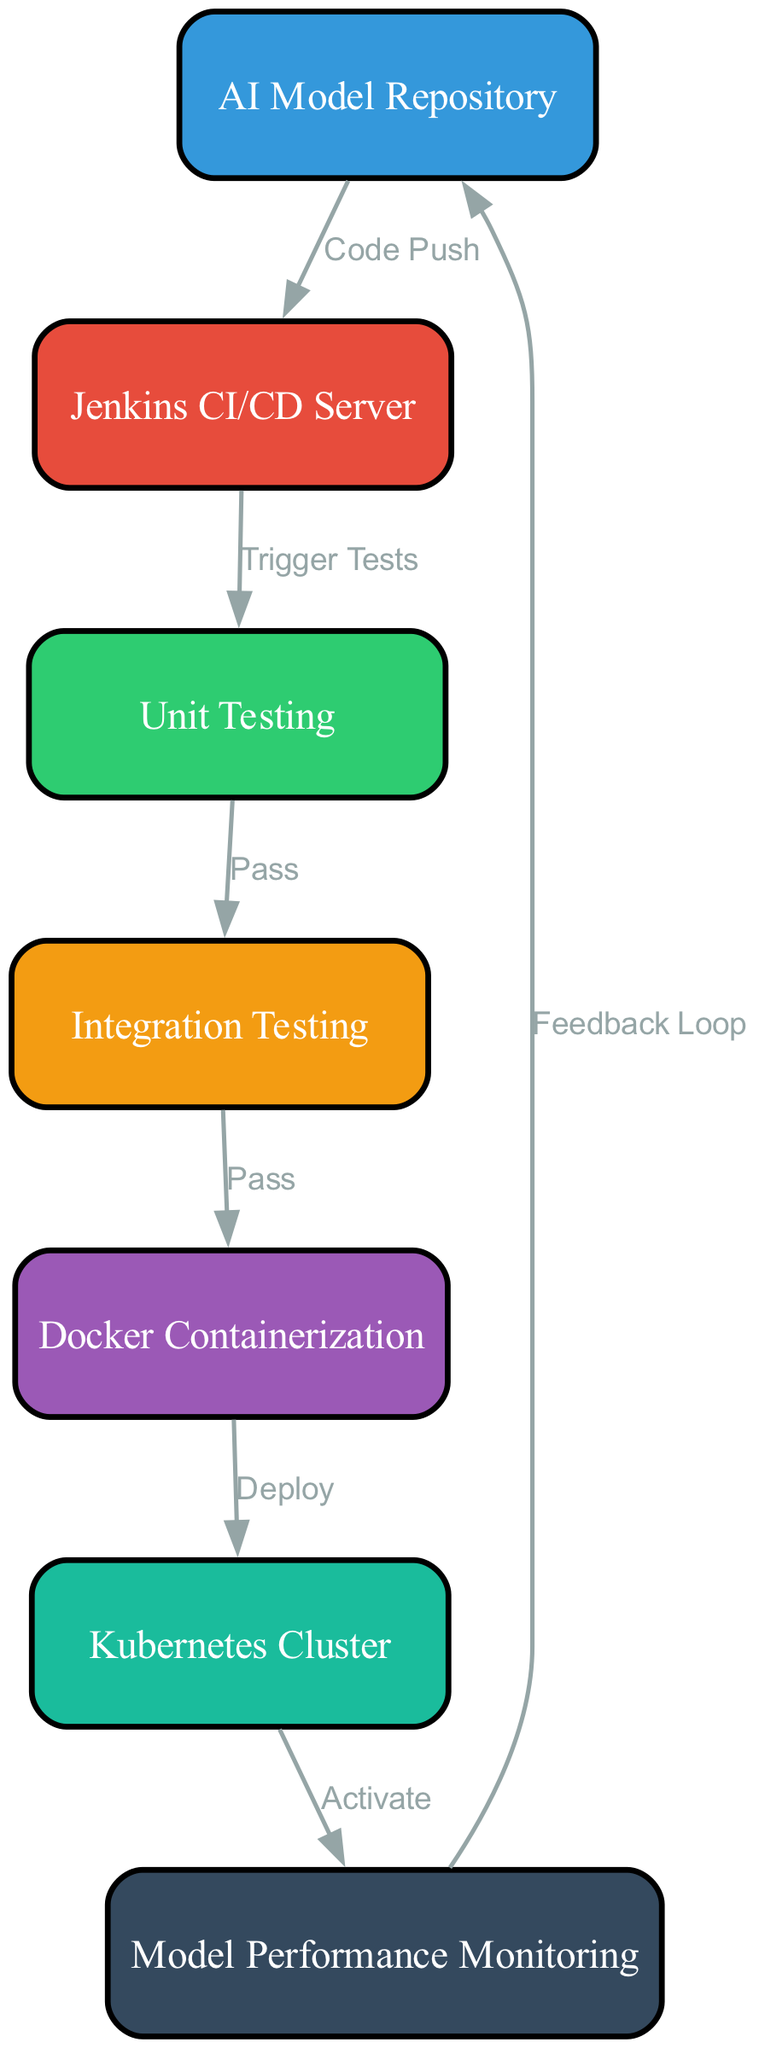What is the starting node of the pipeline? The diagram shows that the starting node is the "AI Model Repository," which is where the code push occurs initially.
Answer: AI Model Repository How many nodes are present in the diagram? By counting each of the nodes listed, we find there are seven nodes in total: AI Model Repository, Jenkins CI/CD Server, Unit Testing, Integration Testing, Docker Containerization, Kubernetes Cluster, and Model Performance Monitoring.
Answer: 7 What is the relationship between the Jenkins CI/CD Server and Unit Testing? The edge connecting these two nodes is labeled "Trigger Tests," indicating that the Jenkins CI/CD Server triggers the unit testing process after receiving a code push.
Answer: Trigger Tests Which node follows Integration Testing? The diagram shows that Integration Testing is followed by Docker Containerization, since the edge labeled "Pass" directly leads from Integration Testing to Docker Containerization.
Answer: Docker Containerization What node is activated after the Kubernetes Cluster? The edge labeled "Activate" leads from the Kubernetes Cluster to Model Performance Monitoring, indicating that Model Performance Monitoring is activated after deploying to the Kubernetes Cluster.
Answer: Model Performance Monitoring What occurs if Unit Testing fails? The diagram specifies that there is no edge leading from Unit Testing to Integration Testing if the tests do not pass. Therefore, we can infer that if Unit Testing fails, the pipeline would halt at that point.
Answer: Halt What is the feedback loop in the pipeline? The diagram illustrates a feedback loop from Model Performance Monitoring back to the AI Model Repository, signifying that performance monitoring results inform and possibly modify the model in the repository.
Answer: Feedback Loop Which node is responsible for the deployment of AI models? The diagram indicates that Docker Containerization is responsible for deployment since it is the node that directly connects to the Kubernetes Cluster with the edge labeled "Deploy."
Answer: Docker Containerization 